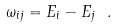<formula> <loc_0><loc_0><loc_500><loc_500>\omega _ { i j } = E _ { i } - E _ { j } \ .</formula> 